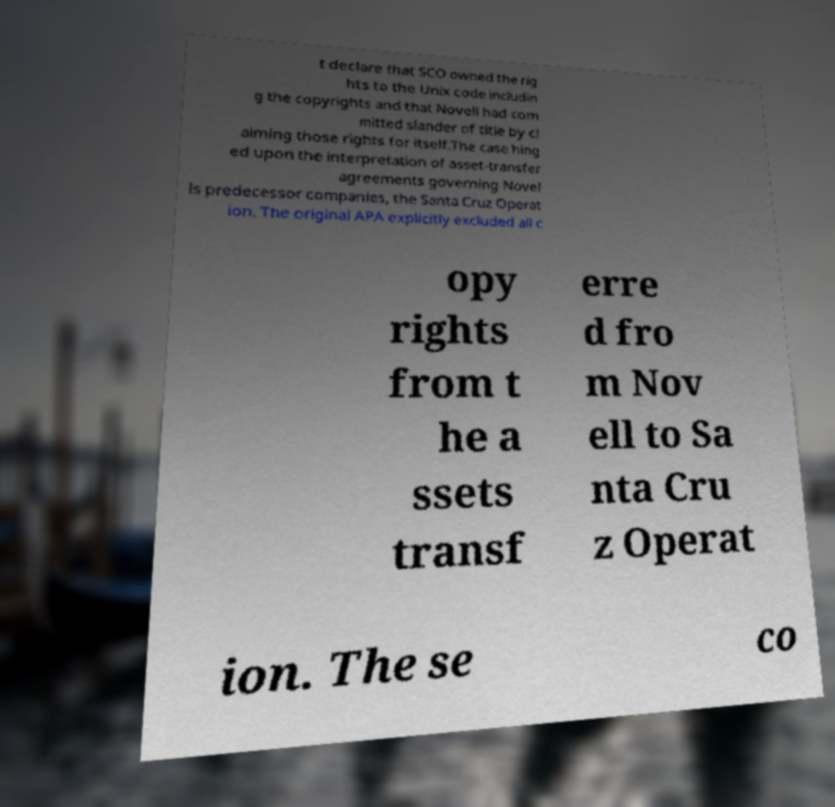Can you read and provide the text displayed in the image?This photo seems to have some interesting text. Can you extract and type it out for me? t declare that SCO owned the rig hts to the Unix code includin g the copyrights and that Novell had com mitted slander of title by cl aiming those rights for itself.The case hing ed upon the interpretation of asset-transfer agreements governing Novel ls predecessor companies, the Santa Cruz Operat ion. The original APA explicitly excluded all c opy rights from t he a ssets transf erre d fro m Nov ell to Sa nta Cru z Operat ion. The se co 